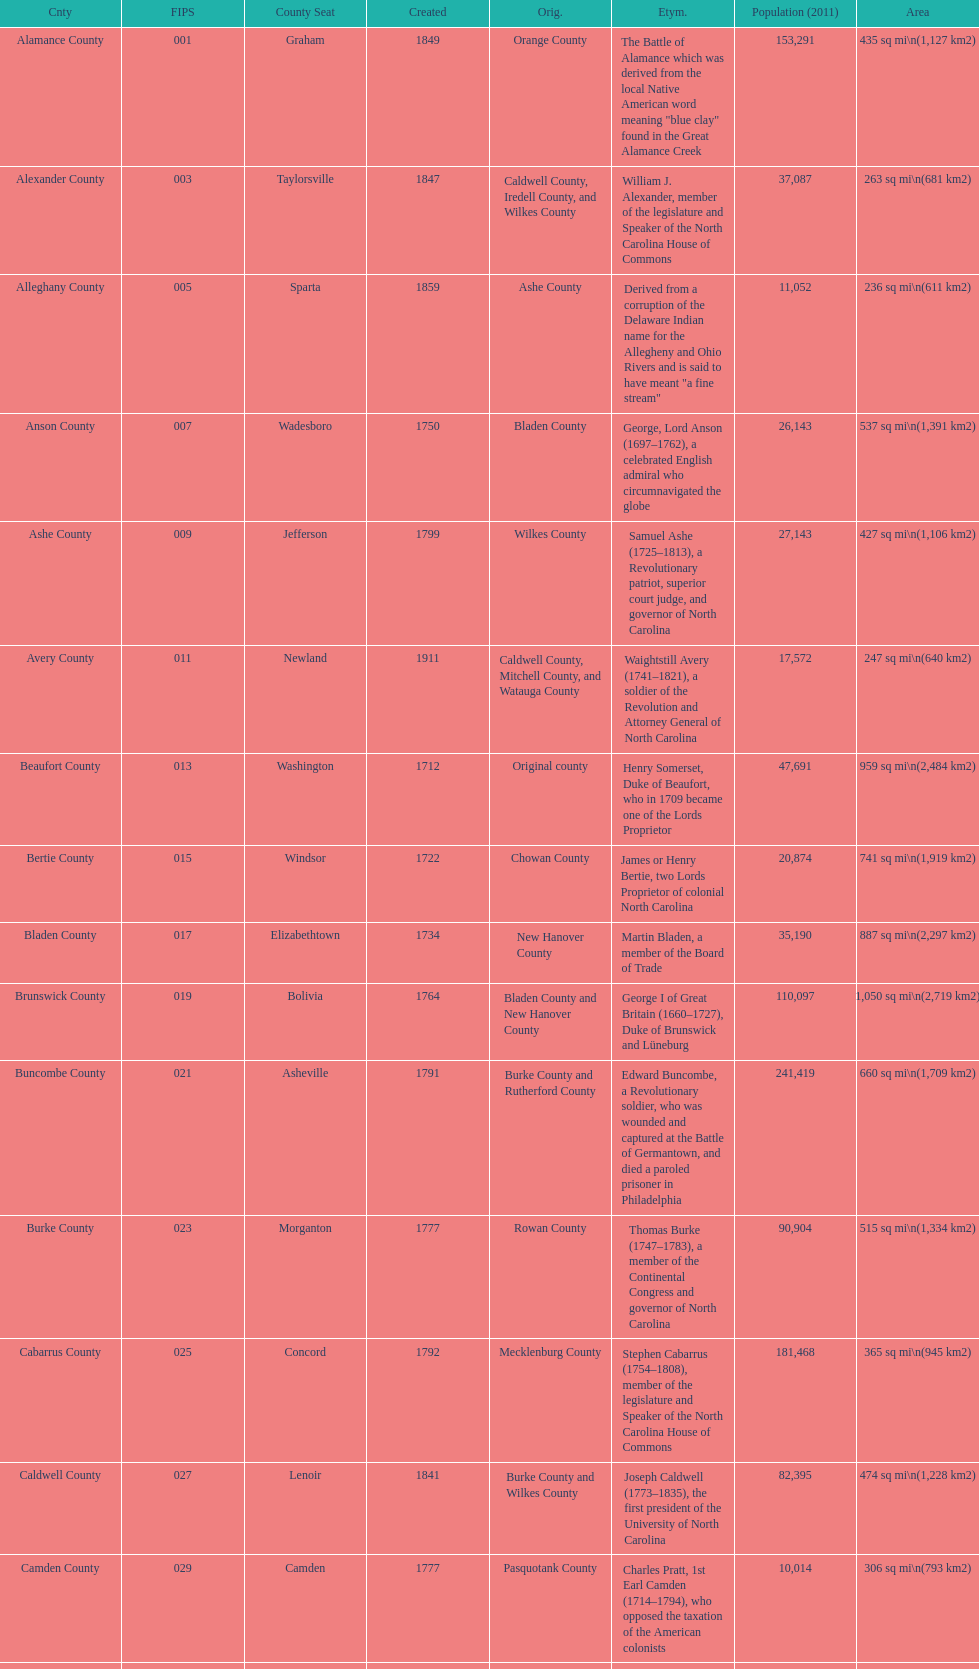What is the only county whose name comes from a battle? Alamance County. 